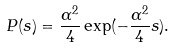Convert formula to latex. <formula><loc_0><loc_0><loc_500><loc_500>P ( s ) = \frac { \alpha ^ { 2 } } { 4 } \exp ( - \frac { \alpha ^ { 2 } } { 4 } s ) .</formula> 